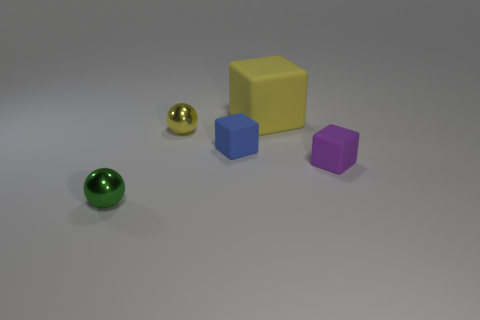Add 5 yellow metallic objects. How many objects exist? 10 Subtract all blocks. How many objects are left? 2 Add 2 purple rubber blocks. How many purple rubber blocks exist? 3 Subtract 0 cyan cylinders. How many objects are left? 5 Subtract all green metal balls. Subtract all brown metal blocks. How many objects are left? 4 Add 2 small green metallic balls. How many small green metallic balls are left? 3 